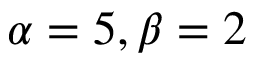<formula> <loc_0><loc_0><loc_500><loc_500>\alpha = 5 , \beta = 2</formula> 